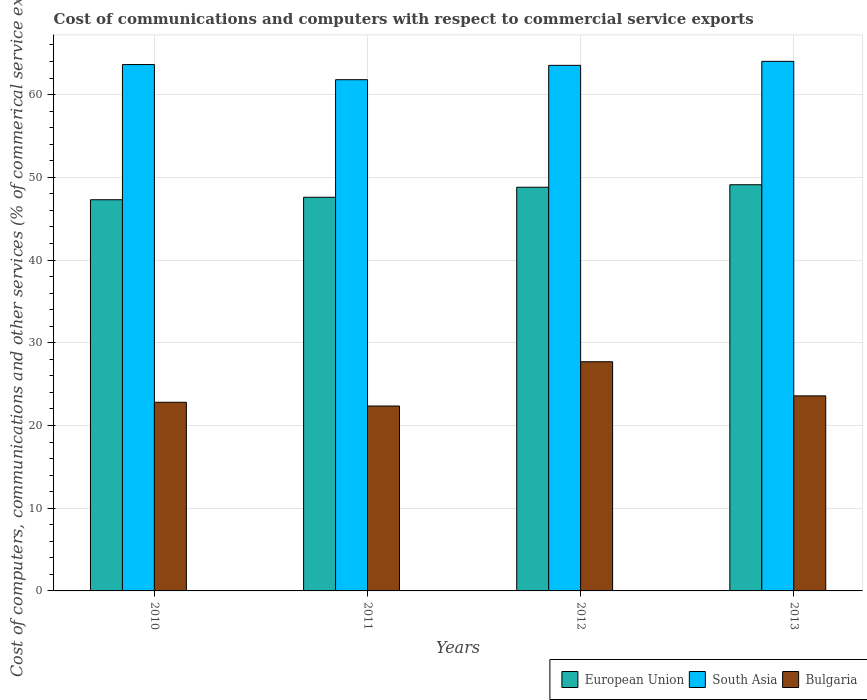How many different coloured bars are there?
Offer a very short reply. 3. How many bars are there on the 2nd tick from the left?
Keep it short and to the point. 3. How many bars are there on the 4th tick from the right?
Your answer should be compact. 3. What is the cost of communications and computers in Bulgaria in 2010?
Your answer should be compact. 22.81. Across all years, what is the maximum cost of communications and computers in Bulgaria?
Provide a short and direct response. 27.71. Across all years, what is the minimum cost of communications and computers in European Union?
Your response must be concise. 47.29. What is the total cost of communications and computers in Bulgaria in the graph?
Keep it short and to the point. 96.45. What is the difference between the cost of communications and computers in European Union in 2011 and that in 2013?
Provide a short and direct response. -1.51. What is the difference between the cost of communications and computers in Bulgaria in 2012 and the cost of communications and computers in South Asia in 2013?
Keep it short and to the point. -36.32. What is the average cost of communications and computers in Bulgaria per year?
Offer a terse response. 24.11. In the year 2010, what is the difference between the cost of communications and computers in European Union and cost of communications and computers in South Asia?
Offer a very short reply. -16.34. What is the ratio of the cost of communications and computers in South Asia in 2010 to that in 2012?
Give a very brief answer. 1. What is the difference between the highest and the second highest cost of communications and computers in European Union?
Provide a succinct answer. 0.3. What is the difference between the highest and the lowest cost of communications and computers in South Asia?
Your answer should be compact. 2.22. In how many years, is the cost of communications and computers in European Union greater than the average cost of communications and computers in European Union taken over all years?
Provide a succinct answer. 2. Is the sum of the cost of communications and computers in European Union in 2012 and 2013 greater than the maximum cost of communications and computers in South Asia across all years?
Give a very brief answer. Yes. What does the 2nd bar from the left in 2013 represents?
Your answer should be very brief. South Asia. What does the 1st bar from the right in 2011 represents?
Keep it short and to the point. Bulgaria. How many bars are there?
Provide a short and direct response. 12. How many years are there in the graph?
Offer a terse response. 4. What is the difference between two consecutive major ticks on the Y-axis?
Provide a succinct answer. 10. Are the values on the major ticks of Y-axis written in scientific E-notation?
Your answer should be very brief. No. Does the graph contain any zero values?
Your answer should be very brief. No. Where does the legend appear in the graph?
Your response must be concise. Bottom right. What is the title of the graph?
Offer a very short reply. Cost of communications and computers with respect to commercial service exports. What is the label or title of the X-axis?
Your answer should be compact. Years. What is the label or title of the Y-axis?
Provide a succinct answer. Cost of computers, communications and other services (% of commerical service exports). What is the Cost of computers, communications and other services (% of commerical service exports) in European Union in 2010?
Your answer should be very brief. 47.29. What is the Cost of computers, communications and other services (% of commerical service exports) of South Asia in 2010?
Provide a succinct answer. 63.64. What is the Cost of computers, communications and other services (% of commerical service exports) in Bulgaria in 2010?
Keep it short and to the point. 22.81. What is the Cost of computers, communications and other services (% of commerical service exports) of European Union in 2011?
Ensure brevity in your answer.  47.59. What is the Cost of computers, communications and other services (% of commerical service exports) in South Asia in 2011?
Provide a short and direct response. 61.81. What is the Cost of computers, communications and other services (% of commerical service exports) of Bulgaria in 2011?
Provide a succinct answer. 22.35. What is the Cost of computers, communications and other services (% of commerical service exports) of European Union in 2012?
Make the answer very short. 48.8. What is the Cost of computers, communications and other services (% of commerical service exports) of South Asia in 2012?
Provide a short and direct response. 63.54. What is the Cost of computers, communications and other services (% of commerical service exports) of Bulgaria in 2012?
Offer a very short reply. 27.71. What is the Cost of computers, communications and other services (% of commerical service exports) in European Union in 2013?
Provide a succinct answer. 49.11. What is the Cost of computers, communications and other services (% of commerical service exports) of South Asia in 2013?
Offer a terse response. 64.02. What is the Cost of computers, communications and other services (% of commerical service exports) in Bulgaria in 2013?
Give a very brief answer. 23.58. Across all years, what is the maximum Cost of computers, communications and other services (% of commerical service exports) of European Union?
Offer a very short reply. 49.11. Across all years, what is the maximum Cost of computers, communications and other services (% of commerical service exports) of South Asia?
Make the answer very short. 64.02. Across all years, what is the maximum Cost of computers, communications and other services (% of commerical service exports) of Bulgaria?
Offer a terse response. 27.71. Across all years, what is the minimum Cost of computers, communications and other services (% of commerical service exports) of European Union?
Your answer should be very brief. 47.29. Across all years, what is the minimum Cost of computers, communications and other services (% of commerical service exports) in South Asia?
Offer a terse response. 61.81. Across all years, what is the minimum Cost of computers, communications and other services (% of commerical service exports) of Bulgaria?
Make the answer very short. 22.35. What is the total Cost of computers, communications and other services (% of commerical service exports) in European Union in the graph?
Your answer should be very brief. 192.79. What is the total Cost of computers, communications and other services (% of commerical service exports) of South Asia in the graph?
Offer a terse response. 253. What is the total Cost of computers, communications and other services (% of commerical service exports) of Bulgaria in the graph?
Ensure brevity in your answer.  96.45. What is the difference between the Cost of computers, communications and other services (% of commerical service exports) in European Union in 2010 and that in 2011?
Keep it short and to the point. -0.3. What is the difference between the Cost of computers, communications and other services (% of commerical service exports) in South Asia in 2010 and that in 2011?
Your response must be concise. 1.83. What is the difference between the Cost of computers, communications and other services (% of commerical service exports) of Bulgaria in 2010 and that in 2011?
Give a very brief answer. 0.45. What is the difference between the Cost of computers, communications and other services (% of commerical service exports) in European Union in 2010 and that in 2012?
Your answer should be very brief. -1.51. What is the difference between the Cost of computers, communications and other services (% of commerical service exports) in South Asia in 2010 and that in 2012?
Provide a short and direct response. 0.1. What is the difference between the Cost of computers, communications and other services (% of commerical service exports) of Bulgaria in 2010 and that in 2012?
Your answer should be compact. -4.9. What is the difference between the Cost of computers, communications and other services (% of commerical service exports) in European Union in 2010 and that in 2013?
Your answer should be very brief. -1.81. What is the difference between the Cost of computers, communications and other services (% of commerical service exports) of South Asia in 2010 and that in 2013?
Ensure brevity in your answer.  -0.39. What is the difference between the Cost of computers, communications and other services (% of commerical service exports) of Bulgaria in 2010 and that in 2013?
Make the answer very short. -0.78. What is the difference between the Cost of computers, communications and other services (% of commerical service exports) of European Union in 2011 and that in 2012?
Make the answer very short. -1.21. What is the difference between the Cost of computers, communications and other services (% of commerical service exports) of South Asia in 2011 and that in 2012?
Offer a terse response. -1.73. What is the difference between the Cost of computers, communications and other services (% of commerical service exports) of Bulgaria in 2011 and that in 2012?
Keep it short and to the point. -5.35. What is the difference between the Cost of computers, communications and other services (% of commerical service exports) of European Union in 2011 and that in 2013?
Keep it short and to the point. -1.51. What is the difference between the Cost of computers, communications and other services (% of commerical service exports) in South Asia in 2011 and that in 2013?
Give a very brief answer. -2.22. What is the difference between the Cost of computers, communications and other services (% of commerical service exports) in Bulgaria in 2011 and that in 2013?
Provide a short and direct response. -1.23. What is the difference between the Cost of computers, communications and other services (% of commerical service exports) of European Union in 2012 and that in 2013?
Your response must be concise. -0.3. What is the difference between the Cost of computers, communications and other services (% of commerical service exports) of South Asia in 2012 and that in 2013?
Ensure brevity in your answer.  -0.48. What is the difference between the Cost of computers, communications and other services (% of commerical service exports) of Bulgaria in 2012 and that in 2013?
Offer a terse response. 4.12. What is the difference between the Cost of computers, communications and other services (% of commerical service exports) of European Union in 2010 and the Cost of computers, communications and other services (% of commerical service exports) of South Asia in 2011?
Provide a succinct answer. -14.51. What is the difference between the Cost of computers, communications and other services (% of commerical service exports) of European Union in 2010 and the Cost of computers, communications and other services (% of commerical service exports) of Bulgaria in 2011?
Your answer should be very brief. 24.94. What is the difference between the Cost of computers, communications and other services (% of commerical service exports) of South Asia in 2010 and the Cost of computers, communications and other services (% of commerical service exports) of Bulgaria in 2011?
Your answer should be very brief. 41.28. What is the difference between the Cost of computers, communications and other services (% of commerical service exports) of European Union in 2010 and the Cost of computers, communications and other services (% of commerical service exports) of South Asia in 2012?
Give a very brief answer. -16.25. What is the difference between the Cost of computers, communications and other services (% of commerical service exports) in European Union in 2010 and the Cost of computers, communications and other services (% of commerical service exports) in Bulgaria in 2012?
Your answer should be very brief. 19.59. What is the difference between the Cost of computers, communications and other services (% of commerical service exports) in South Asia in 2010 and the Cost of computers, communications and other services (% of commerical service exports) in Bulgaria in 2012?
Provide a short and direct response. 35.93. What is the difference between the Cost of computers, communications and other services (% of commerical service exports) of European Union in 2010 and the Cost of computers, communications and other services (% of commerical service exports) of South Asia in 2013?
Your answer should be compact. -16.73. What is the difference between the Cost of computers, communications and other services (% of commerical service exports) in European Union in 2010 and the Cost of computers, communications and other services (% of commerical service exports) in Bulgaria in 2013?
Your answer should be compact. 23.71. What is the difference between the Cost of computers, communications and other services (% of commerical service exports) in South Asia in 2010 and the Cost of computers, communications and other services (% of commerical service exports) in Bulgaria in 2013?
Your answer should be compact. 40.05. What is the difference between the Cost of computers, communications and other services (% of commerical service exports) in European Union in 2011 and the Cost of computers, communications and other services (% of commerical service exports) in South Asia in 2012?
Your answer should be very brief. -15.95. What is the difference between the Cost of computers, communications and other services (% of commerical service exports) of European Union in 2011 and the Cost of computers, communications and other services (% of commerical service exports) of Bulgaria in 2012?
Offer a very short reply. 19.89. What is the difference between the Cost of computers, communications and other services (% of commerical service exports) in South Asia in 2011 and the Cost of computers, communications and other services (% of commerical service exports) in Bulgaria in 2012?
Keep it short and to the point. 34.1. What is the difference between the Cost of computers, communications and other services (% of commerical service exports) of European Union in 2011 and the Cost of computers, communications and other services (% of commerical service exports) of South Asia in 2013?
Keep it short and to the point. -16.43. What is the difference between the Cost of computers, communications and other services (% of commerical service exports) of European Union in 2011 and the Cost of computers, communications and other services (% of commerical service exports) of Bulgaria in 2013?
Offer a terse response. 24.01. What is the difference between the Cost of computers, communications and other services (% of commerical service exports) in South Asia in 2011 and the Cost of computers, communications and other services (% of commerical service exports) in Bulgaria in 2013?
Offer a very short reply. 38.22. What is the difference between the Cost of computers, communications and other services (% of commerical service exports) of European Union in 2012 and the Cost of computers, communications and other services (% of commerical service exports) of South Asia in 2013?
Offer a very short reply. -15.22. What is the difference between the Cost of computers, communications and other services (% of commerical service exports) of European Union in 2012 and the Cost of computers, communications and other services (% of commerical service exports) of Bulgaria in 2013?
Provide a short and direct response. 25.22. What is the difference between the Cost of computers, communications and other services (% of commerical service exports) in South Asia in 2012 and the Cost of computers, communications and other services (% of commerical service exports) in Bulgaria in 2013?
Give a very brief answer. 39.96. What is the average Cost of computers, communications and other services (% of commerical service exports) of European Union per year?
Offer a terse response. 48.2. What is the average Cost of computers, communications and other services (% of commerical service exports) of South Asia per year?
Ensure brevity in your answer.  63.25. What is the average Cost of computers, communications and other services (% of commerical service exports) of Bulgaria per year?
Offer a terse response. 24.11. In the year 2010, what is the difference between the Cost of computers, communications and other services (% of commerical service exports) in European Union and Cost of computers, communications and other services (% of commerical service exports) in South Asia?
Your answer should be very brief. -16.34. In the year 2010, what is the difference between the Cost of computers, communications and other services (% of commerical service exports) in European Union and Cost of computers, communications and other services (% of commerical service exports) in Bulgaria?
Your answer should be compact. 24.49. In the year 2010, what is the difference between the Cost of computers, communications and other services (% of commerical service exports) in South Asia and Cost of computers, communications and other services (% of commerical service exports) in Bulgaria?
Offer a very short reply. 40.83. In the year 2011, what is the difference between the Cost of computers, communications and other services (% of commerical service exports) of European Union and Cost of computers, communications and other services (% of commerical service exports) of South Asia?
Your answer should be very brief. -14.21. In the year 2011, what is the difference between the Cost of computers, communications and other services (% of commerical service exports) in European Union and Cost of computers, communications and other services (% of commerical service exports) in Bulgaria?
Your response must be concise. 25.24. In the year 2011, what is the difference between the Cost of computers, communications and other services (% of commerical service exports) of South Asia and Cost of computers, communications and other services (% of commerical service exports) of Bulgaria?
Provide a short and direct response. 39.45. In the year 2012, what is the difference between the Cost of computers, communications and other services (% of commerical service exports) in European Union and Cost of computers, communications and other services (% of commerical service exports) in South Asia?
Offer a terse response. -14.74. In the year 2012, what is the difference between the Cost of computers, communications and other services (% of commerical service exports) of European Union and Cost of computers, communications and other services (% of commerical service exports) of Bulgaria?
Your answer should be very brief. 21.1. In the year 2012, what is the difference between the Cost of computers, communications and other services (% of commerical service exports) of South Asia and Cost of computers, communications and other services (% of commerical service exports) of Bulgaria?
Your response must be concise. 35.83. In the year 2013, what is the difference between the Cost of computers, communications and other services (% of commerical service exports) of European Union and Cost of computers, communications and other services (% of commerical service exports) of South Asia?
Ensure brevity in your answer.  -14.92. In the year 2013, what is the difference between the Cost of computers, communications and other services (% of commerical service exports) of European Union and Cost of computers, communications and other services (% of commerical service exports) of Bulgaria?
Your answer should be very brief. 25.52. In the year 2013, what is the difference between the Cost of computers, communications and other services (% of commerical service exports) in South Asia and Cost of computers, communications and other services (% of commerical service exports) in Bulgaria?
Provide a short and direct response. 40.44. What is the ratio of the Cost of computers, communications and other services (% of commerical service exports) of South Asia in 2010 to that in 2011?
Make the answer very short. 1.03. What is the ratio of the Cost of computers, communications and other services (% of commerical service exports) of Bulgaria in 2010 to that in 2011?
Your answer should be compact. 1.02. What is the ratio of the Cost of computers, communications and other services (% of commerical service exports) of European Union in 2010 to that in 2012?
Provide a succinct answer. 0.97. What is the ratio of the Cost of computers, communications and other services (% of commerical service exports) in South Asia in 2010 to that in 2012?
Give a very brief answer. 1. What is the ratio of the Cost of computers, communications and other services (% of commerical service exports) of Bulgaria in 2010 to that in 2012?
Keep it short and to the point. 0.82. What is the ratio of the Cost of computers, communications and other services (% of commerical service exports) of European Union in 2010 to that in 2013?
Offer a terse response. 0.96. What is the ratio of the Cost of computers, communications and other services (% of commerical service exports) in South Asia in 2010 to that in 2013?
Make the answer very short. 0.99. What is the ratio of the Cost of computers, communications and other services (% of commerical service exports) of Bulgaria in 2010 to that in 2013?
Your answer should be very brief. 0.97. What is the ratio of the Cost of computers, communications and other services (% of commerical service exports) of European Union in 2011 to that in 2012?
Give a very brief answer. 0.98. What is the ratio of the Cost of computers, communications and other services (% of commerical service exports) of South Asia in 2011 to that in 2012?
Provide a succinct answer. 0.97. What is the ratio of the Cost of computers, communications and other services (% of commerical service exports) in Bulgaria in 2011 to that in 2012?
Give a very brief answer. 0.81. What is the ratio of the Cost of computers, communications and other services (% of commerical service exports) of European Union in 2011 to that in 2013?
Your answer should be compact. 0.97. What is the ratio of the Cost of computers, communications and other services (% of commerical service exports) in South Asia in 2011 to that in 2013?
Provide a short and direct response. 0.97. What is the ratio of the Cost of computers, communications and other services (% of commerical service exports) of Bulgaria in 2011 to that in 2013?
Your response must be concise. 0.95. What is the ratio of the Cost of computers, communications and other services (% of commerical service exports) in South Asia in 2012 to that in 2013?
Provide a short and direct response. 0.99. What is the ratio of the Cost of computers, communications and other services (% of commerical service exports) of Bulgaria in 2012 to that in 2013?
Make the answer very short. 1.17. What is the difference between the highest and the second highest Cost of computers, communications and other services (% of commerical service exports) in European Union?
Keep it short and to the point. 0.3. What is the difference between the highest and the second highest Cost of computers, communications and other services (% of commerical service exports) of South Asia?
Ensure brevity in your answer.  0.39. What is the difference between the highest and the second highest Cost of computers, communications and other services (% of commerical service exports) of Bulgaria?
Make the answer very short. 4.12. What is the difference between the highest and the lowest Cost of computers, communications and other services (% of commerical service exports) of European Union?
Give a very brief answer. 1.81. What is the difference between the highest and the lowest Cost of computers, communications and other services (% of commerical service exports) in South Asia?
Offer a terse response. 2.22. What is the difference between the highest and the lowest Cost of computers, communications and other services (% of commerical service exports) in Bulgaria?
Your response must be concise. 5.35. 